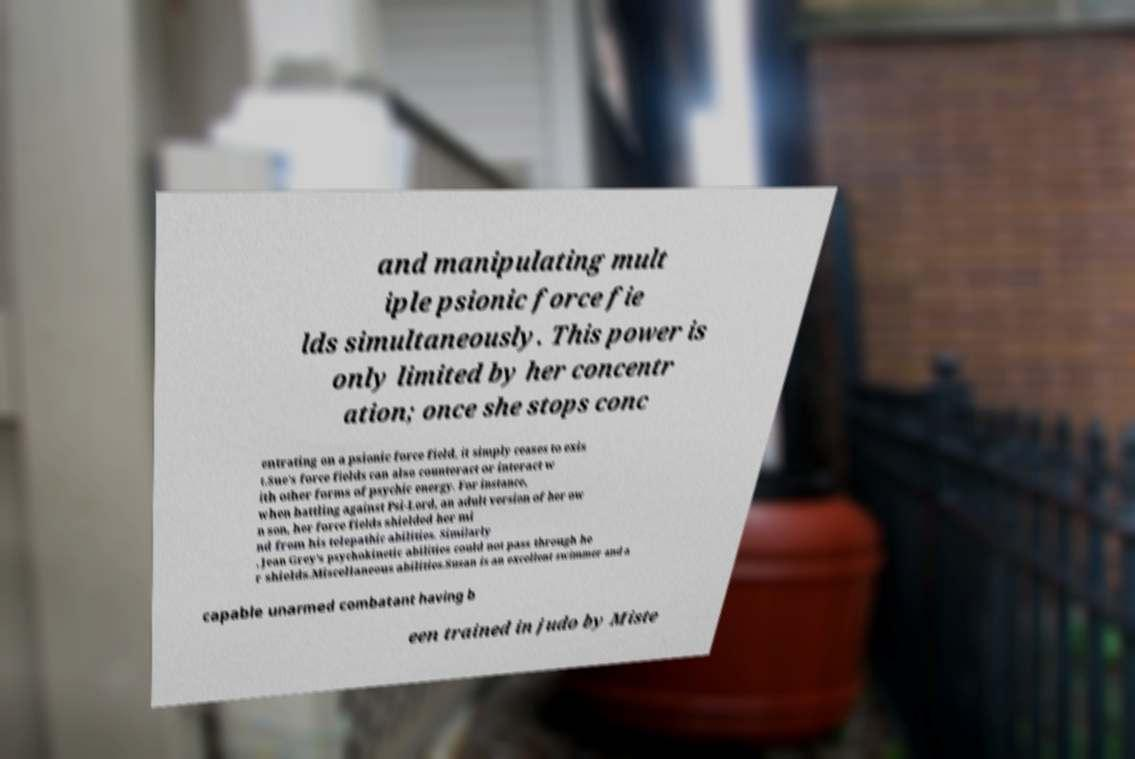For documentation purposes, I need the text within this image transcribed. Could you provide that? and manipulating mult iple psionic force fie lds simultaneously. This power is only limited by her concentr ation; once she stops conc entrating on a psionic force field, it simply ceases to exis t.Sue's force fields can also counteract or interact w ith other forms of psychic energy. For instance, when battling against Psi-Lord, an adult version of her ow n son, her force fields shielded her mi nd from his telepathic abilities. Similarly , Jean Grey's psychokinetic abilities could not pass through he r shields.Miscellaneous abilities.Susan is an excellent swimmer and a capable unarmed combatant having b een trained in judo by Miste 